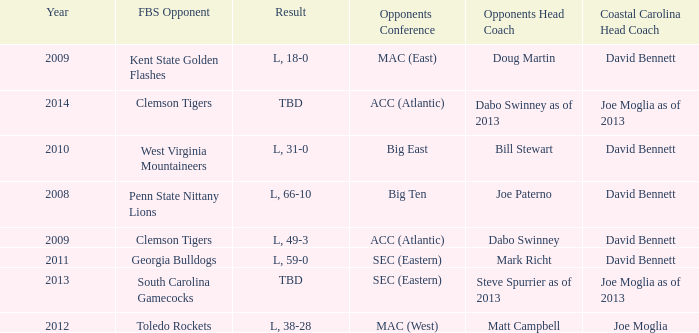What was the result when then opponents conference was Mac (east)? L, 18-0. 